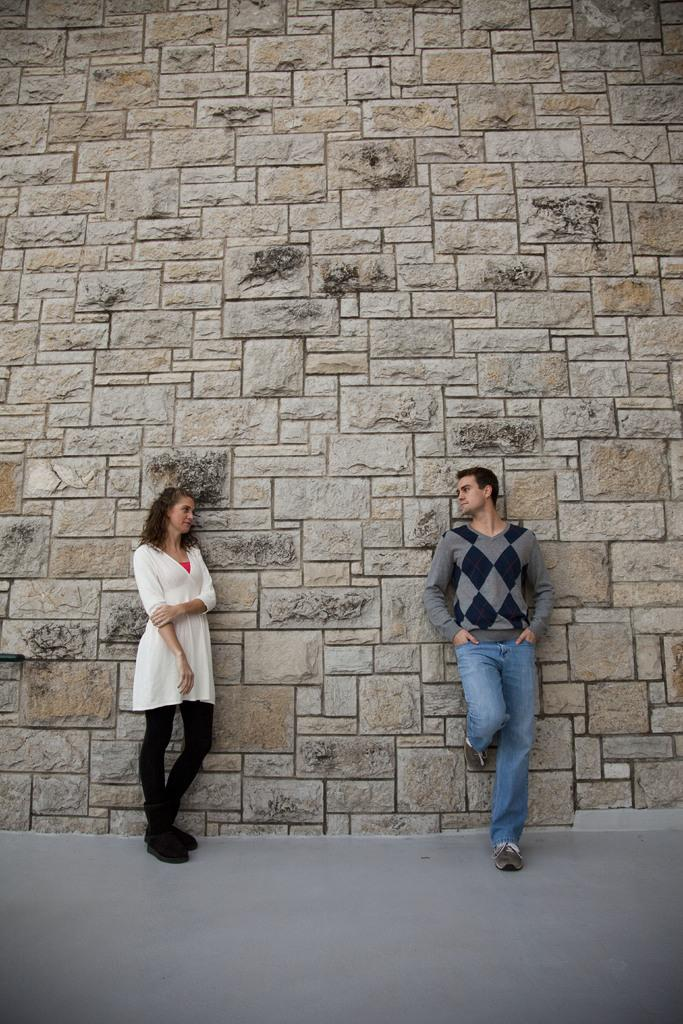How many people are present in the image? There are two people, a man and a woman, present in the image. What are the man and woman doing in the image? Both the man and woman are standing on the floor. What can be seen on the wall in the image? There are tiles on the wall. What type of fiction is the man reading in the image? There is no book or any form of fiction present in the image. Can you describe the cushion on the floor where the man and woman are standing? There is no cushion present on the floor in the image. 